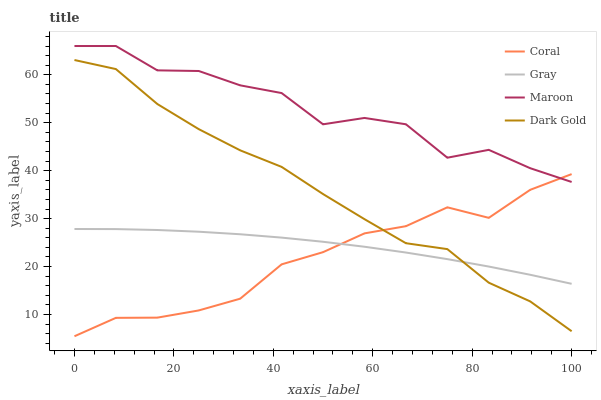Does Coral have the minimum area under the curve?
Answer yes or no. Yes. Does Maroon have the maximum area under the curve?
Answer yes or no. Yes. Does Maroon have the minimum area under the curve?
Answer yes or no. No. Does Coral have the maximum area under the curve?
Answer yes or no. No. Is Gray the smoothest?
Answer yes or no. Yes. Is Maroon the roughest?
Answer yes or no. Yes. Is Coral the smoothest?
Answer yes or no. No. Is Coral the roughest?
Answer yes or no. No. Does Maroon have the lowest value?
Answer yes or no. No. Does Coral have the highest value?
Answer yes or no. No. Is Dark Gold less than Maroon?
Answer yes or no. Yes. Is Maroon greater than Dark Gold?
Answer yes or no. Yes. Does Dark Gold intersect Maroon?
Answer yes or no. No. 